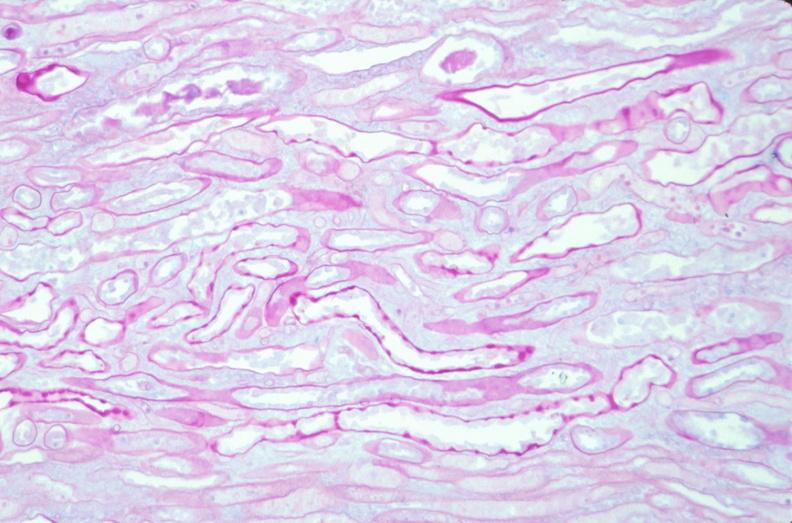does this image show kidney, thickened and hyalinized basement membranes due to diabetes mellitus, pas?
Answer the question using a single word or phrase. Yes 